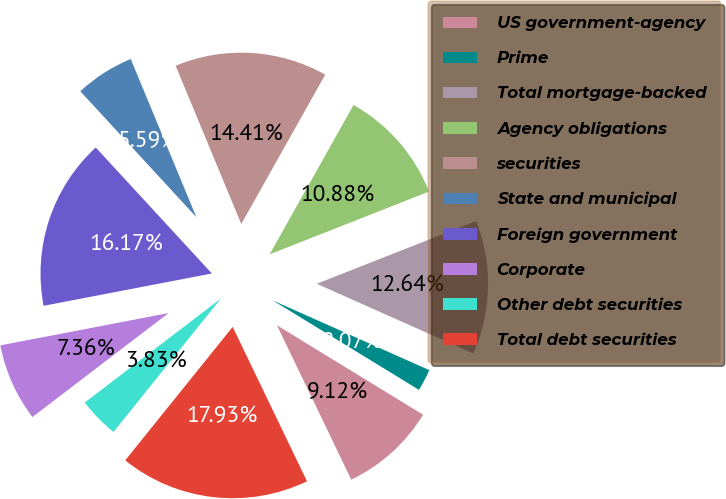Convert chart to OTSL. <chart><loc_0><loc_0><loc_500><loc_500><pie_chart><fcel>US government-agency<fcel>Prime<fcel>Total mortgage-backed<fcel>Agency obligations<fcel>securities<fcel>State and municipal<fcel>Foreign government<fcel>Corporate<fcel>Other debt securities<fcel>Total debt securities<nl><fcel>9.12%<fcel>2.07%<fcel>12.64%<fcel>10.88%<fcel>14.41%<fcel>5.59%<fcel>16.17%<fcel>7.36%<fcel>3.83%<fcel>17.93%<nl></chart> 